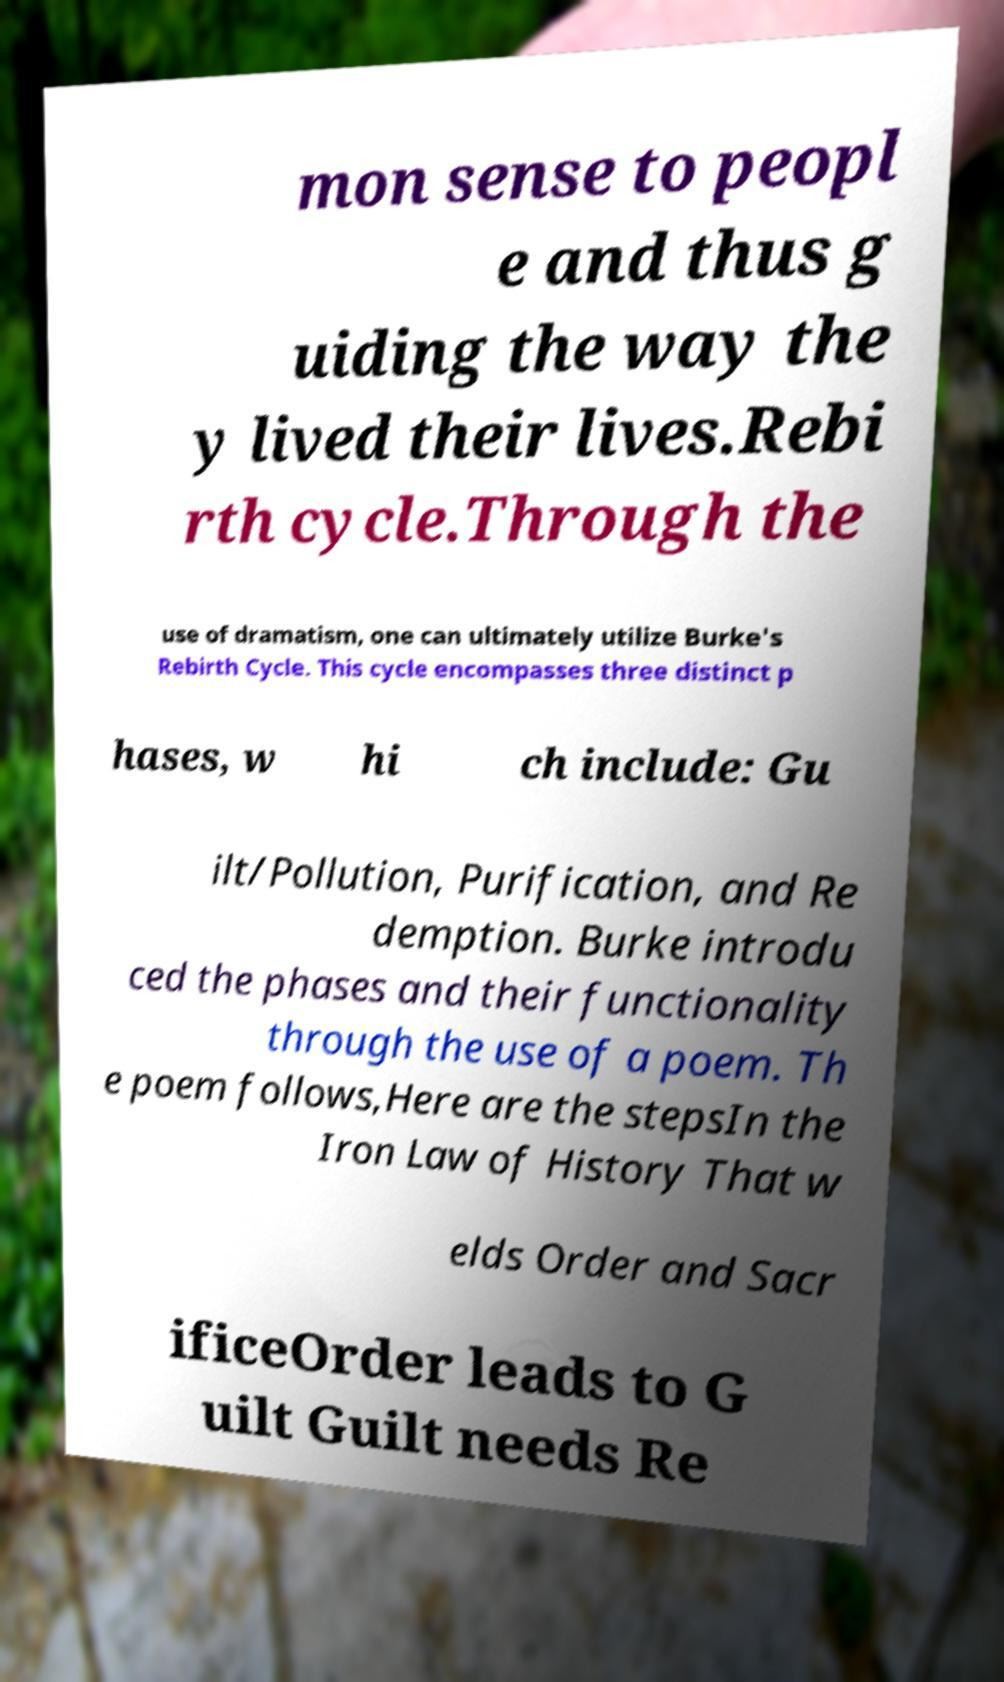There's text embedded in this image that I need extracted. Can you transcribe it verbatim? mon sense to peopl e and thus g uiding the way the y lived their lives.Rebi rth cycle.Through the use of dramatism, one can ultimately utilize Burke's Rebirth Cycle. This cycle encompasses three distinct p hases, w hi ch include: Gu ilt/Pollution, Purification, and Re demption. Burke introdu ced the phases and their functionality through the use of a poem. Th e poem follows,Here are the stepsIn the Iron Law of History That w elds Order and Sacr ificeOrder leads to G uilt Guilt needs Re 